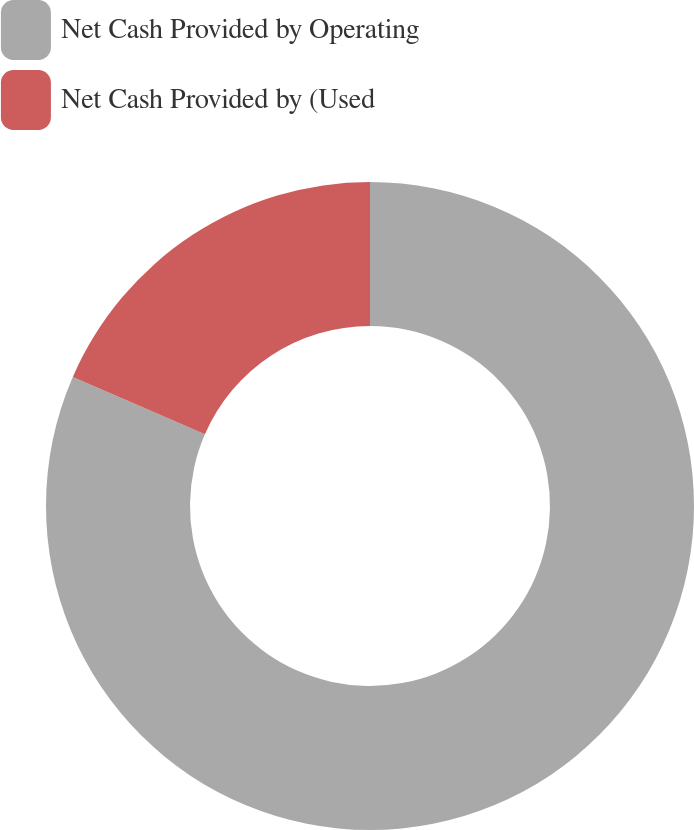Convert chart. <chart><loc_0><loc_0><loc_500><loc_500><pie_chart><fcel>Net Cash Provided by Operating<fcel>Net Cash Provided by (Used<nl><fcel>81.52%<fcel>18.48%<nl></chart> 